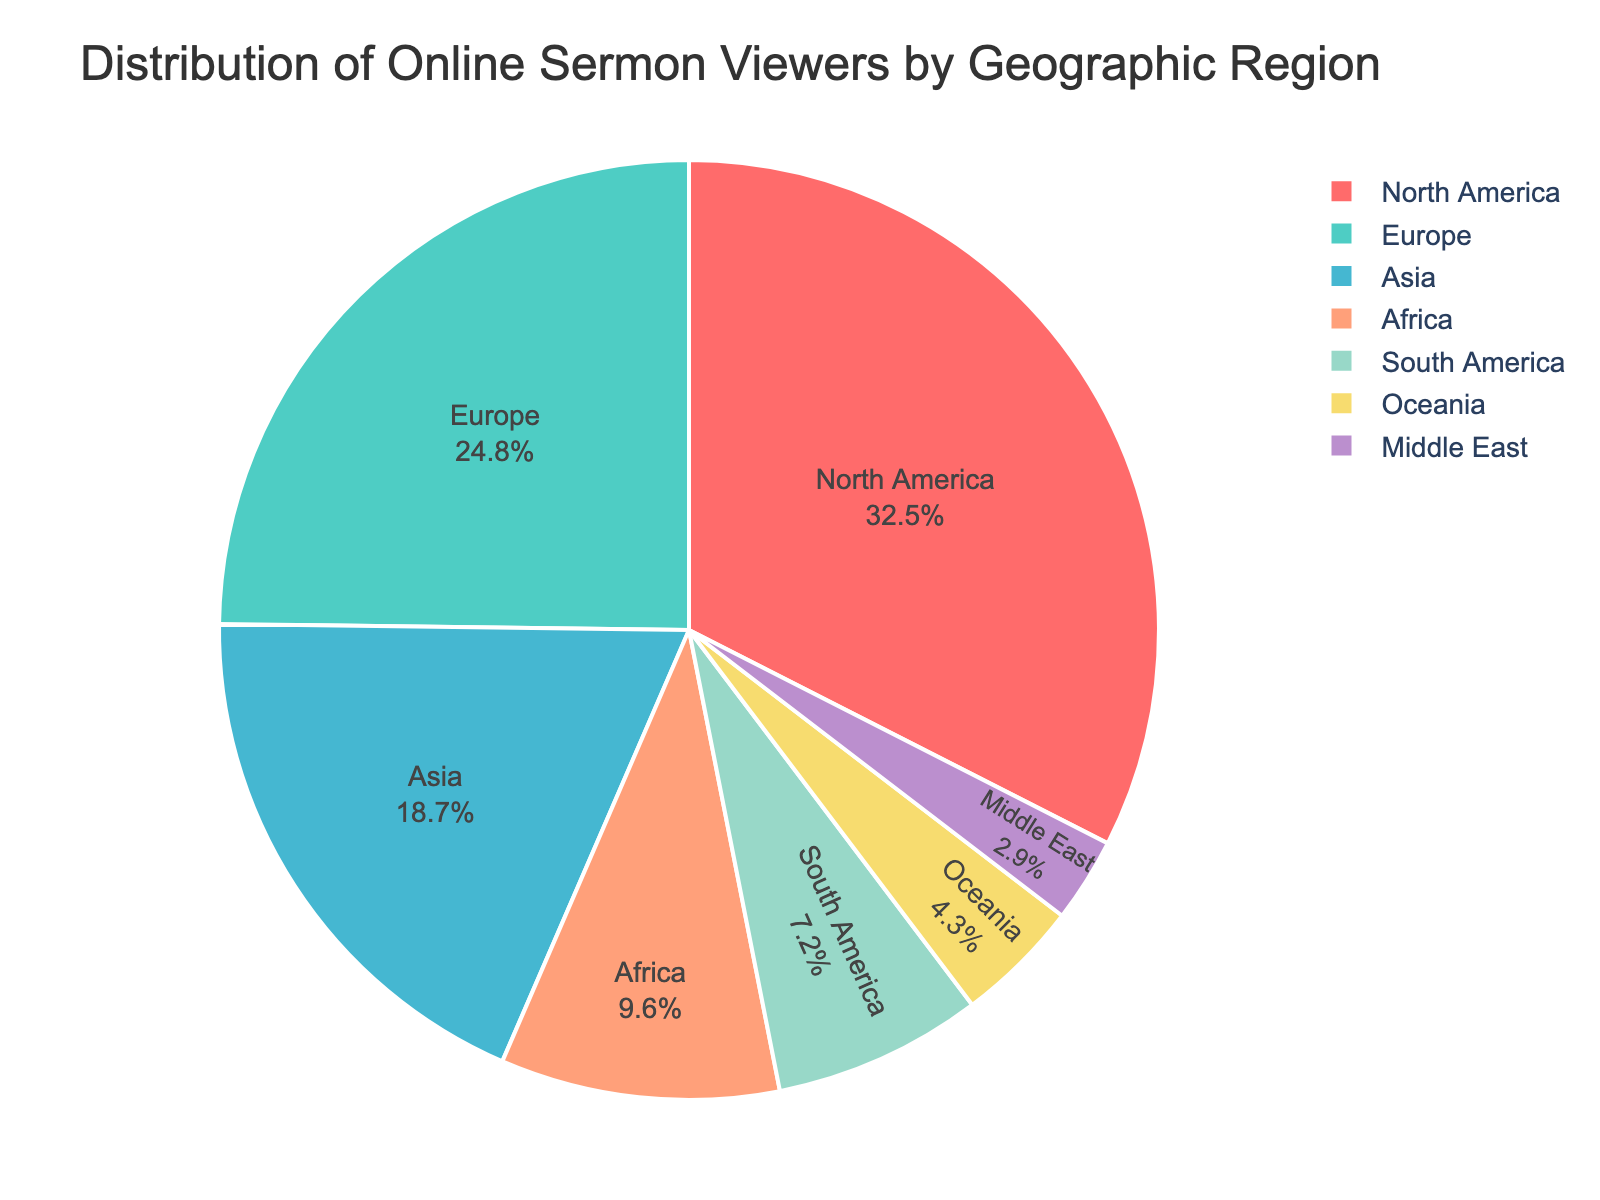What percentage of viewers are from North America? Look at the section of the pie chart labeled "North America". The percentage is displayed inside or adjacent to that section.
Answer: 32.5% How does the percentage of viewers from Europe compare to those from Asia? Identify the percentage values for Europe (24.8%) and Asia (18.7%) from the pie chart. Then compare these values directly.
Answer: Europe has a higher percentage than Asia What is the combined percentage of viewers from South America and Oceania? Find the percentage values for South America (7.2%) and Oceania (4.3%) in the pie chart. Add these values together: 7.2% + 4.3%.
Answer: 11.5% Which region has the smallest percentage of viewers? Identify the region with the smallest segment in the pie chart and check the percentage label for that segment.
Answer: Middle East What fraction of the viewers come from Asia compared to the total number of viewers from Europe, Africa, and South America combined? Find the percentages for Asia (18.7%), Europe (24.8%), Africa (9.6%), and South America (7.2%). Calculate the combined percentage for Europe, Africa, and South America: 24.8% + 9.6% + 7.2% = 41.6%. Then, divide Asia's percentage by the combined percentage: 18.7% / 41.6%.
Answer: ~0.45 What is the difference in viewership percentage between the region with the highest percentage and the region with the second-highest percentage? Identify the regions with the highest (North America: 32.5%) and second-highest (Europe: 24.8%) percentages. Subtract the second-highest percentage from the highest percentage: 32.5% - 24.8%.
Answer: 7.7% Which two regions together make up approximately one-third of the total viewership? Look for regions whose combined percentages add up to around 33.3%. Combining Europe (24.8%) and the Middle East (2.9%) results in 27.7%, while combining Asia (18.7%) and Africa (9.6%) results in 28.3%. The closest is found by combining North America (32.5%) and the Middle East (2.9%) which is not exactly one-third. However, no two regions exactly sum up to one-third.
Answer: None exactly one-third 